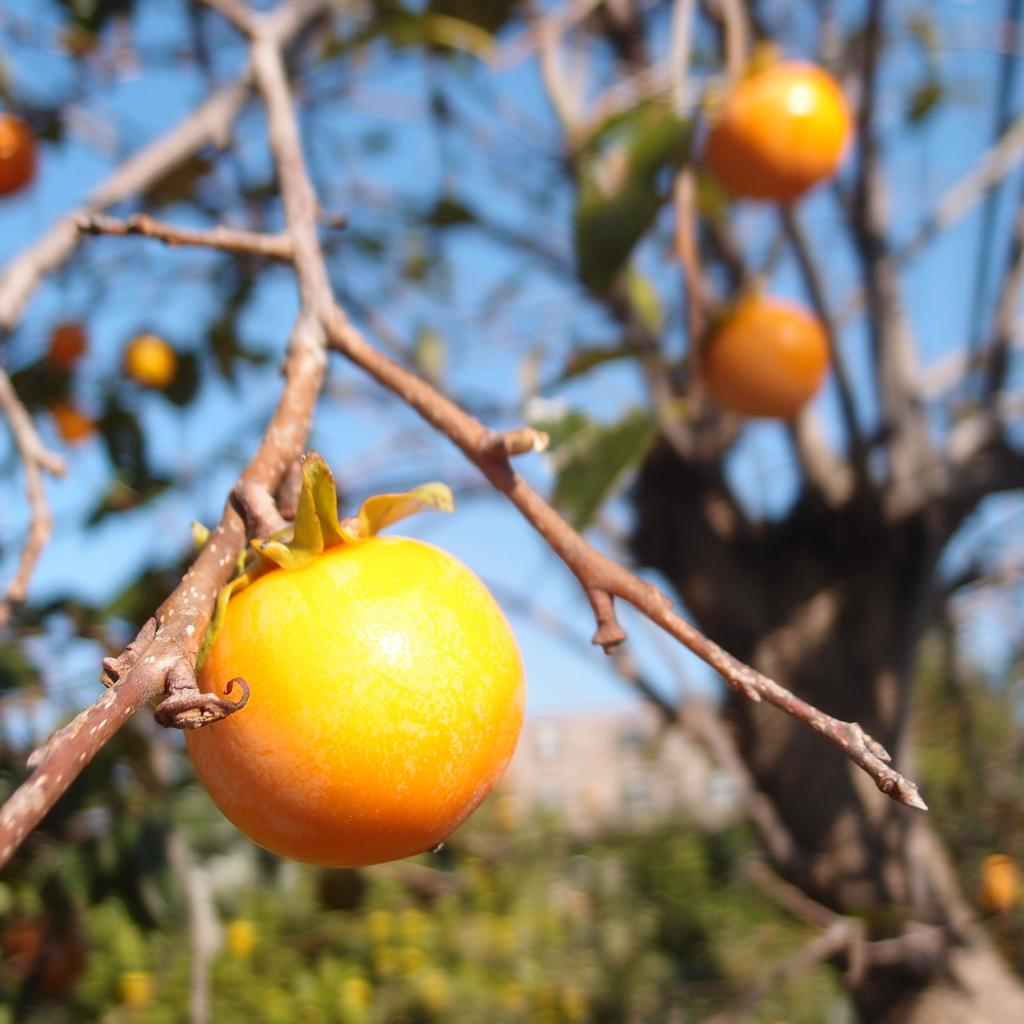What type of vegetation is present on the tree in the image? There are fruits on the tree in the image. What can be seen in the background of the image? The sky is visible in the background of the image. Reasoning: Let's think step by following the steps to produce the conversation. We start by identifying the main subject in the image, which is the tree with fruits. Then, we expand the conversation to include the background of the image, which is the sky. Each question is designed to elicit a specific detail about the image that is known from the provided facts. Absurd Question/Answer: What color is the bead hanging from the tree in the image? There is no bead hanging from the tree in the image. Where is the coat located in the image? There is no coat present in the image. What type of furniture can be seen in the bedroom in the image? There is no bedroom present in the image. 